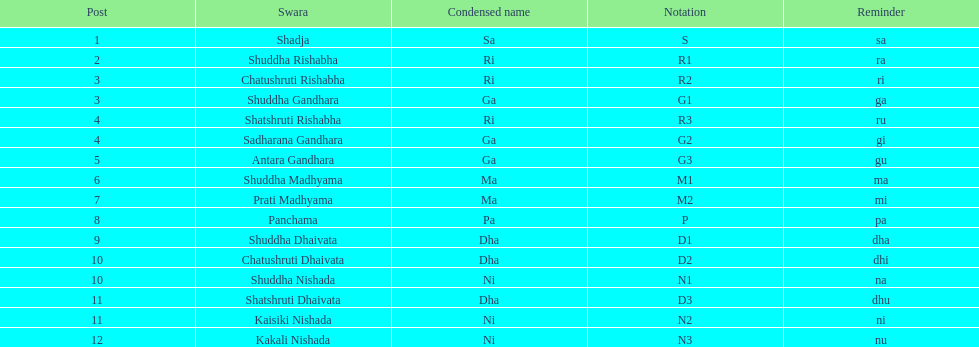What is the name of the swara that comes after panchama? Shuddha Dhaivata. 